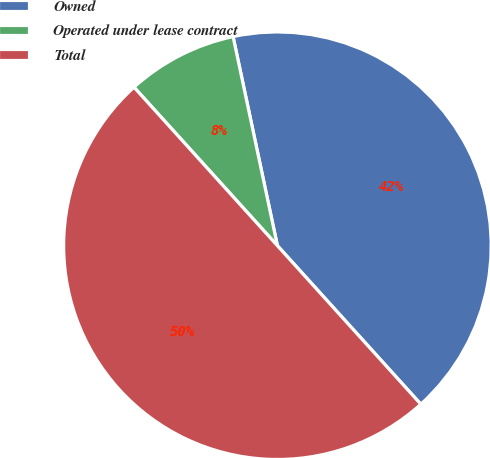Convert chart to OTSL. <chart><loc_0><loc_0><loc_500><loc_500><pie_chart><fcel>Owned<fcel>Operated under lease contract<fcel>Total<nl><fcel>41.62%<fcel>8.38%<fcel>50.0%<nl></chart> 